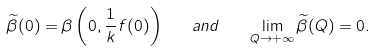<formula> <loc_0><loc_0><loc_500><loc_500>\widetilde { \beta } ( 0 ) = \beta \left ( 0 , \frac { 1 } { k } f ( 0 ) \right ) \quad a n d \quad \lim _ { Q \to + \infty } \widetilde { \beta } ( Q ) = 0 .</formula> 